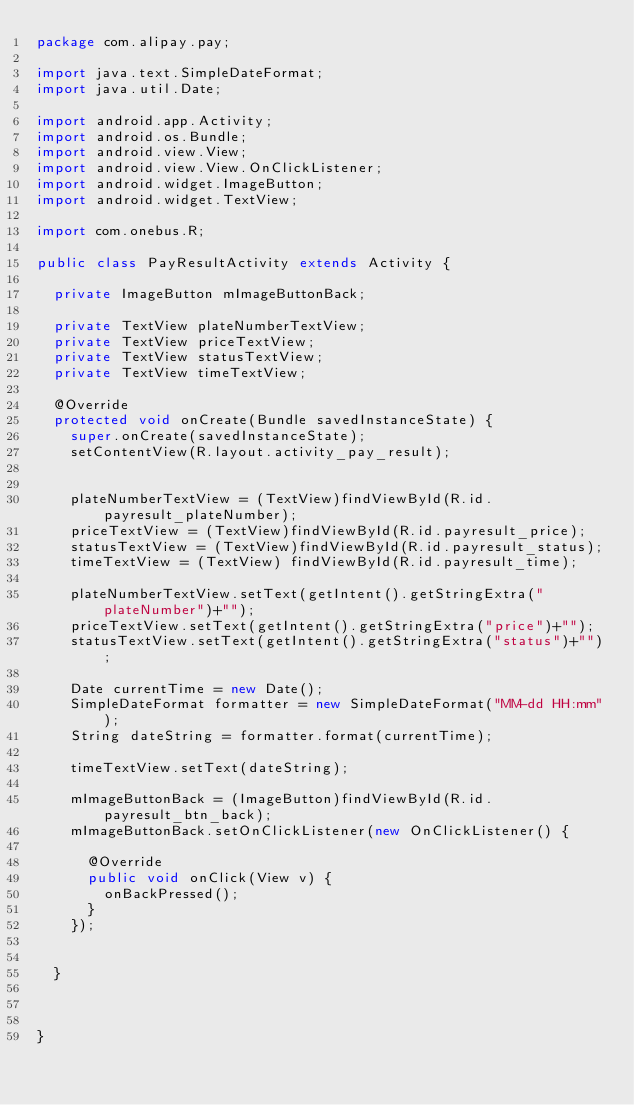Convert code to text. <code><loc_0><loc_0><loc_500><loc_500><_Java_>package com.alipay.pay;

import java.text.SimpleDateFormat;
import java.util.Date;

import android.app.Activity;
import android.os.Bundle;
import android.view.View;
import android.view.View.OnClickListener;
import android.widget.ImageButton;
import android.widget.TextView;

import com.onebus.R;

public class PayResultActivity extends Activity {
	
	private ImageButton mImageButtonBack;
	
	private TextView plateNumberTextView;
	private TextView priceTextView;
	private TextView statusTextView;
	private TextView timeTextView;

	@Override
	protected void onCreate(Bundle savedInstanceState) {
		super.onCreate(savedInstanceState);
		setContentView(R.layout.activity_pay_result);
		
		
		plateNumberTextView = (TextView)findViewById(R.id.payresult_plateNumber);
		priceTextView = (TextView)findViewById(R.id.payresult_price);
		statusTextView = (TextView)findViewById(R.id.payresult_status);
		timeTextView = (TextView) findViewById(R.id.payresult_time);
		
		plateNumberTextView.setText(getIntent().getStringExtra("plateNumber")+"");
		priceTextView.setText(getIntent().getStringExtra("price")+"");
		statusTextView.setText(getIntent().getStringExtra("status")+"");
		
		Date currentTime = new Date();
		SimpleDateFormat formatter = new SimpleDateFormat("MM-dd HH:mm");
		String dateString = formatter.format(currentTime);
		
		timeTextView.setText(dateString);
		
		mImageButtonBack = (ImageButton)findViewById(R.id.payresult_btn_back);
		mImageButtonBack.setOnClickListener(new OnClickListener() {
			
			@Override
			public void onClick(View v) {
				onBackPressed();
			}
		});
		
		
	}

	
	
}
</code> 